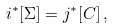<formula> <loc_0><loc_0><loc_500><loc_500>i ^ { * } [ \Sigma ] = j ^ { * } [ C ] \, ,</formula> 